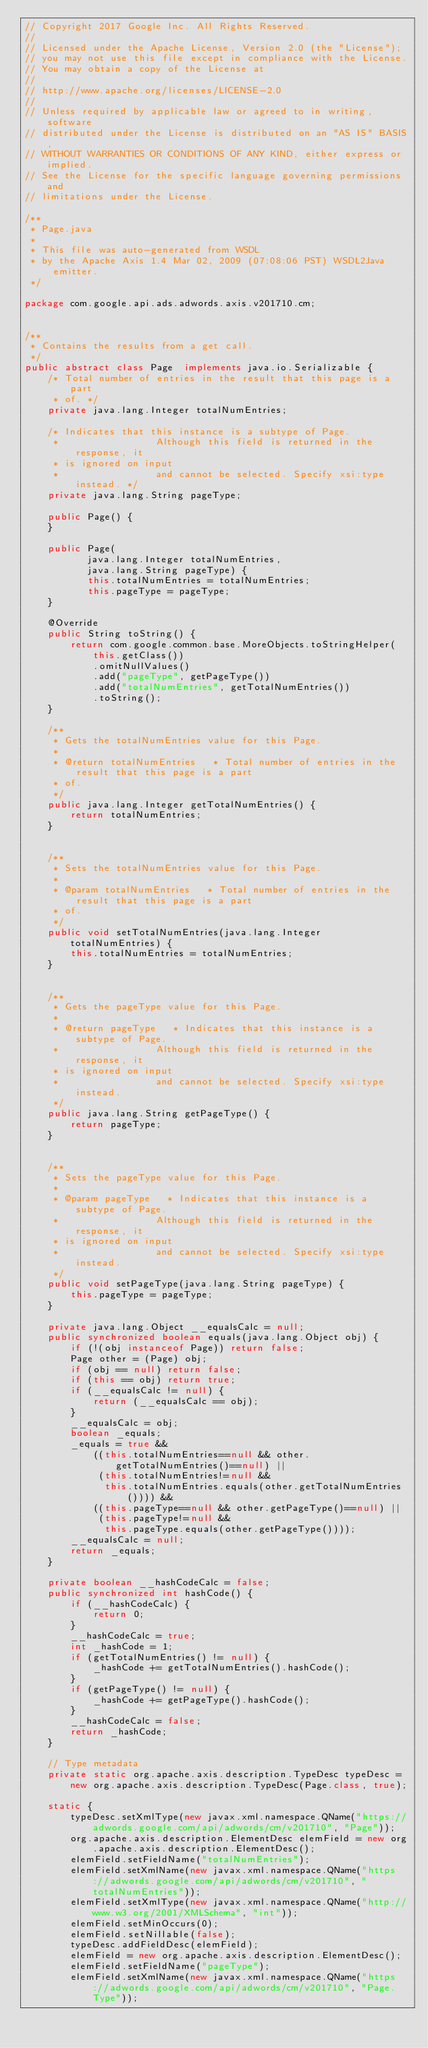<code> <loc_0><loc_0><loc_500><loc_500><_Java_>// Copyright 2017 Google Inc. All Rights Reserved.
//
// Licensed under the Apache License, Version 2.0 (the "License");
// you may not use this file except in compliance with the License.
// You may obtain a copy of the License at
//
// http://www.apache.org/licenses/LICENSE-2.0
//
// Unless required by applicable law or agreed to in writing, software
// distributed under the License is distributed on an "AS IS" BASIS,
// WITHOUT WARRANTIES OR CONDITIONS OF ANY KIND, either express or implied.
// See the License for the specific language governing permissions and
// limitations under the License.

/**
 * Page.java
 *
 * This file was auto-generated from WSDL
 * by the Apache Axis 1.4 Mar 02, 2009 (07:08:06 PST) WSDL2Java emitter.
 */

package com.google.api.ads.adwords.axis.v201710.cm;


/**
 * Contains the results from a get call.
 */
public abstract class Page  implements java.io.Serializable {
    /* Total number of entries in the result that this page is a part
     * of. */
    private java.lang.Integer totalNumEntries;

    /* Indicates that this instance is a subtype of Page.
     *                 Although this field is returned in the response, it
     * is ignored on input
     *                 and cannot be selected. Specify xsi:type instead. */
    private java.lang.String pageType;

    public Page() {
    }

    public Page(
           java.lang.Integer totalNumEntries,
           java.lang.String pageType) {
           this.totalNumEntries = totalNumEntries;
           this.pageType = pageType;
    }

    @Override
    public String toString() {
        return com.google.common.base.MoreObjects.toStringHelper(this.getClass())
            .omitNullValues()
            .add("pageType", getPageType())
            .add("totalNumEntries", getTotalNumEntries())
            .toString();
    }

    /**
     * Gets the totalNumEntries value for this Page.
     * 
     * @return totalNumEntries   * Total number of entries in the result that this page is a part
     * of.
     */
    public java.lang.Integer getTotalNumEntries() {
        return totalNumEntries;
    }


    /**
     * Sets the totalNumEntries value for this Page.
     * 
     * @param totalNumEntries   * Total number of entries in the result that this page is a part
     * of.
     */
    public void setTotalNumEntries(java.lang.Integer totalNumEntries) {
        this.totalNumEntries = totalNumEntries;
    }


    /**
     * Gets the pageType value for this Page.
     * 
     * @return pageType   * Indicates that this instance is a subtype of Page.
     *                 Although this field is returned in the response, it
     * is ignored on input
     *                 and cannot be selected. Specify xsi:type instead.
     */
    public java.lang.String getPageType() {
        return pageType;
    }


    /**
     * Sets the pageType value for this Page.
     * 
     * @param pageType   * Indicates that this instance is a subtype of Page.
     *                 Although this field is returned in the response, it
     * is ignored on input
     *                 and cannot be selected. Specify xsi:type instead.
     */
    public void setPageType(java.lang.String pageType) {
        this.pageType = pageType;
    }

    private java.lang.Object __equalsCalc = null;
    public synchronized boolean equals(java.lang.Object obj) {
        if (!(obj instanceof Page)) return false;
        Page other = (Page) obj;
        if (obj == null) return false;
        if (this == obj) return true;
        if (__equalsCalc != null) {
            return (__equalsCalc == obj);
        }
        __equalsCalc = obj;
        boolean _equals;
        _equals = true && 
            ((this.totalNumEntries==null && other.getTotalNumEntries()==null) || 
             (this.totalNumEntries!=null &&
              this.totalNumEntries.equals(other.getTotalNumEntries()))) &&
            ((this.pageType==null && other.getPageType()==null) || 
             (this.pageType!=null &&
              this.pageType.equals(other.getPageType())));
        __equalsCalc = null;
        return _equals;
    }

    private boolean __hashCodeCalc = false;
    public synchronized int hashCode() {
        if (__hashCodeCalc) {
            return 0;
        }
        __hashCodeCalc = true;
        int _hashCode = 1;
        if (getTotalNumEntries() != null) {
            _hashCode += getTotalNumEntries().hashCode();
        }
        if (getPageType() != null) {
            _hashCode += getPageType().hashCode();
        }
        __hashCodeCalc = false;
        return _hashCode;
    }

    // Type metadata
    private static org.apache.axis.description.TypeDesc typeDesc =
        new org.apache.axis.description.TypeDesc(Page.class, true);

    static {
        typeDesc.setXmlType(new javax.xml.namespace.QName("https://adwords.google.com/api/adwords/cm/v201710", "Page"));
        org.apache.axis.description.ElementDesc elemField = new org.apache.axis.description.ElementDesc();
        elemField.setFieldName("totalNumEntries");
        elemField.setXmlName(new javax.xml.namespace.QName("https://adwords.google.com/api/adwords/cm/v201710", "totalNumEntries"));
        elemField.setXmlType(new javax.xml.namespace.QName("http://www.w3.org/2001/XMLSchema", "int"));
        elemField.setMinOccurs(0);
        elemField.setNillable(false);
        typeDesc.addFieldDesc(elemField);
        elemField = new org.apache.axis.description.ElementDesc();
        elemField.setFieldName("pageType");
        elemField.setXmlName(new javax.xml.namespace.QName("https://adwords.google.com/api/adwords/cm/v201710", "Page.Type"));</code> 